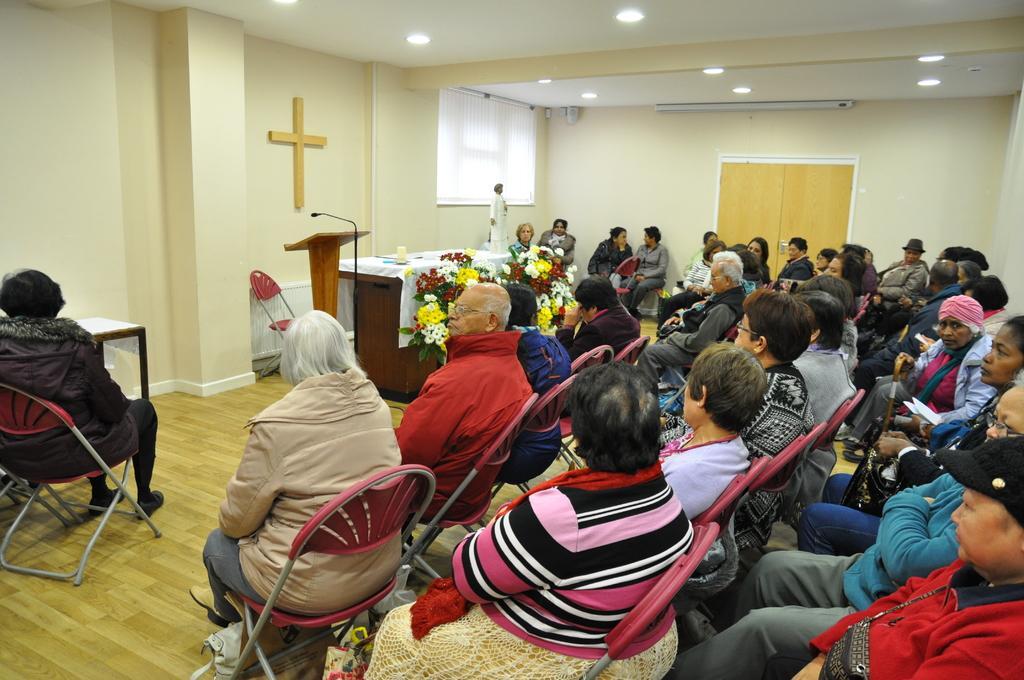Could you give a brief overview of what you see in this image? This picture is of inside the room. On the right there are group of people sitting on the pink color chairs. On the left is a person sitting on the chair and a table. In the background we can see a wall, window blind, door, roof, podium, microphone attached to the stand, table and flowers. 